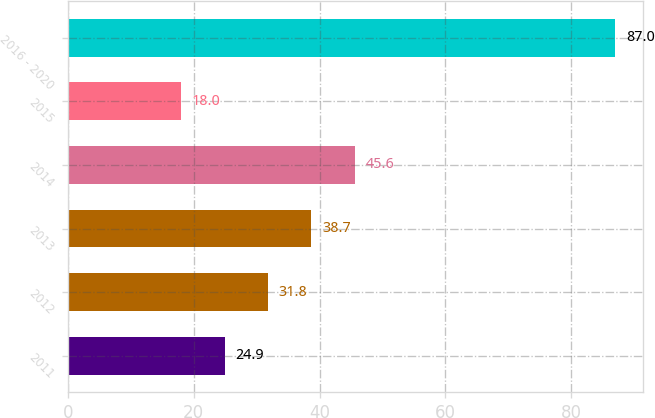Convert chart to OTSL. <chart><loc_0><loc_0><loc_500><loc_500><bar_chart><fcel>2011<fcel>2012<fcel>2013<fcel>2014<fcel>2015<fcel>2016 - 2020<nl><fcel>24.9<fcel>31.8<fcel>38.7<fcel>45.6<fcel>18<fcel>87<nl></chart> 